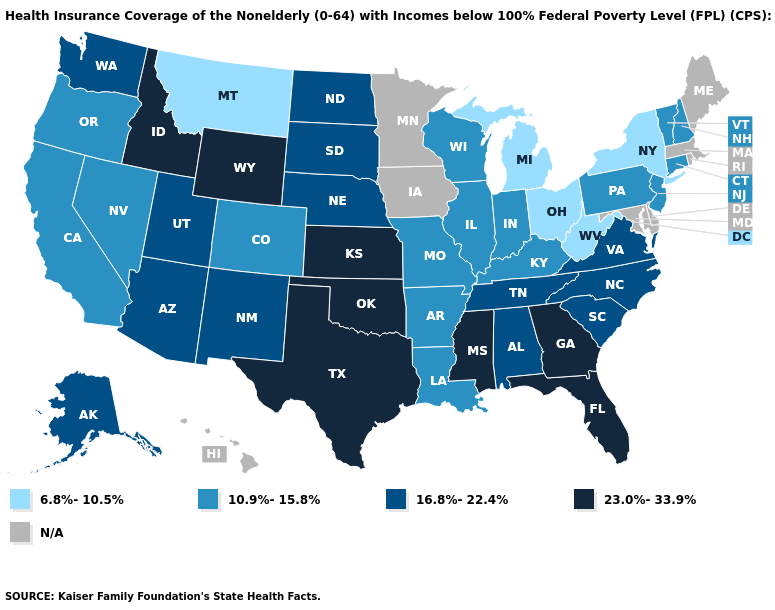Does New Hampshire have the highest value in the USA?
Answer briefly. No. Name the states that have a value in the range N/A?
Keep it brief. Delaware, Hawaii, Iowa, Maine, Maryland, Massachusetts, Minnesota, Rhode Island. What is the value of Ohio?
Answer briefly. 6.8%-10.5%. Name the states that have a value in the range 23.0%-33.9%?
Give a very brief answer. Florida, Georgia, Idaho, Kansas, Mississippi, Oklahoma, Texas, Wyoming. What is the value of Colorado?
Short answer required. 10.9%-15.8%. Does West Virginia have the lowest value in the USA?
Concise answer only. Yes. What is the value of Florida?
Give a very brief answer. 23.0%-33.9%. What is the highest value in states that border Illinois?
Answer briefly. 10.9%-15.8%. Name the states that have a value in the range 23.0%-33.9%?
Answer briefly. Florida, Georgia, Idaho, Kansas, Mississippi, Oklahoma, Texas, Wyoming. What is the lowest value in states that border Delaware?
Quick response, please. 10.9%-15.8%. Among the states that border South Carolina , which have the highest value?
Be succinct. Georgia. Does the map have missing data?
Answer briefly. Yes. What is the value of Kentucky?
Write a very short answer. 10.9%-15.8%. Does California have the highest value in the West?
Concise answer only. No. 